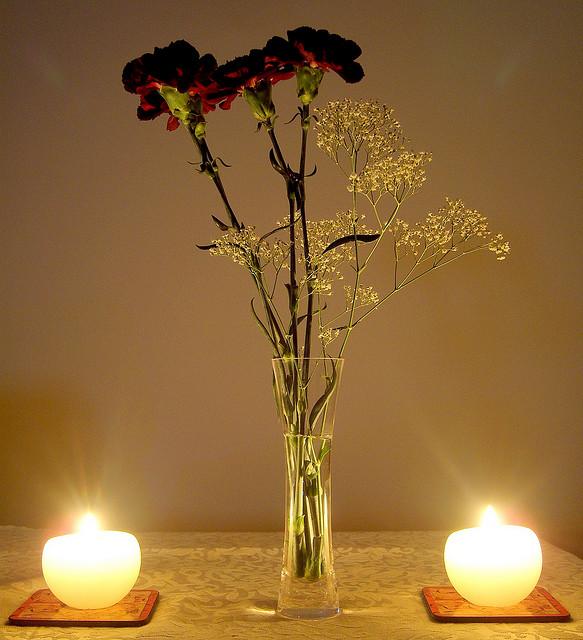How many candles are lit?
Write a very short answer. 2. What color are the carnations?
Answer briefly. Red. What colors of flowers dominate the vase?
Keep it brief. Red. How many carnations are in the vase?
Short answer required. 3. 